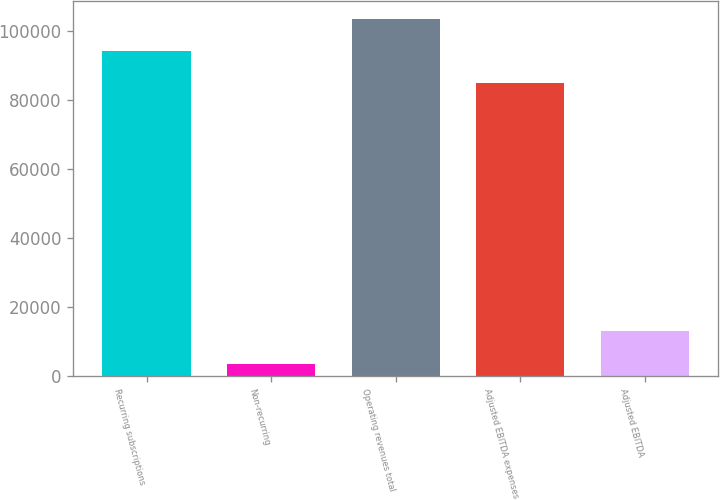<chart> <loc_0><loc_0><loc_500><loc_500><bar_chart><fcel>Recurring subscriptions<fcel>Non-recurring<fcel>Operating revenues total<fcel>Adjusted EBITDA expenses<fcel>Adjusted EBITDA<nl><fcel>94400.1<fcel>3463<fcel>103748<fcel>85052<fcel>12811.1<nl></chart> 